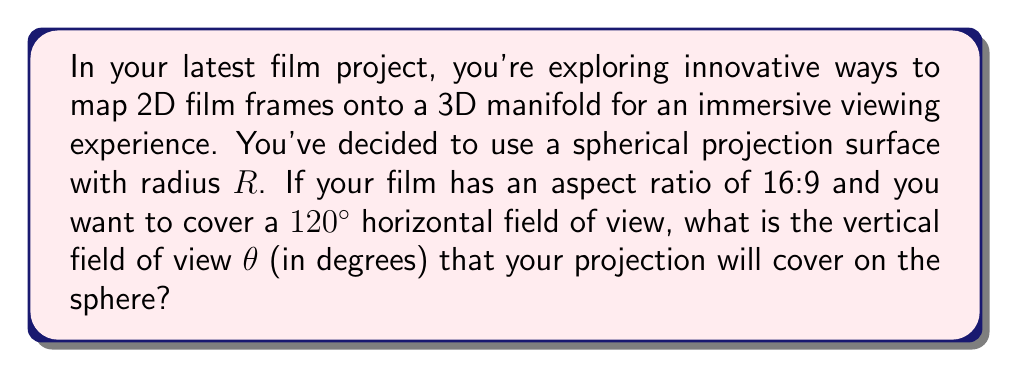Give your solution to this math problem. Let's approach this step-by-step:

1) First, we need to understand the relationship between the aspect ratio and the field of view (FOV) on a sphere.

2) The aspect ratio of 16:9 means that for every 16 units of width, there are 9 units of height.

3) On a sphere, the horizontal and vertical angles subtended by the projection are proportional to these dimensions.

4) We're given that the horizontal FOV is $120°$. Let's call the vertical FOV $\theta$.

5) The ratio of these angles should be equal to the inverse of the aspect ratio:

   $$\frac{\theta}{120°} = \frac{9}{16}$$

6) We can solve this equation for $\theta$:

   $$\theta = 120° \cdot \frac{9}{16}$$

7) Simplifying:

   $$\theta = \frac{1080°}{16} = 67.5°$$

8) It's worth noting that this calculation assumes the projection is centered on the equator of the sphere. In practice, you might need to adjust the projection to account for the viewer's position and the desired center of focus.
Answer: $67.5°$ 